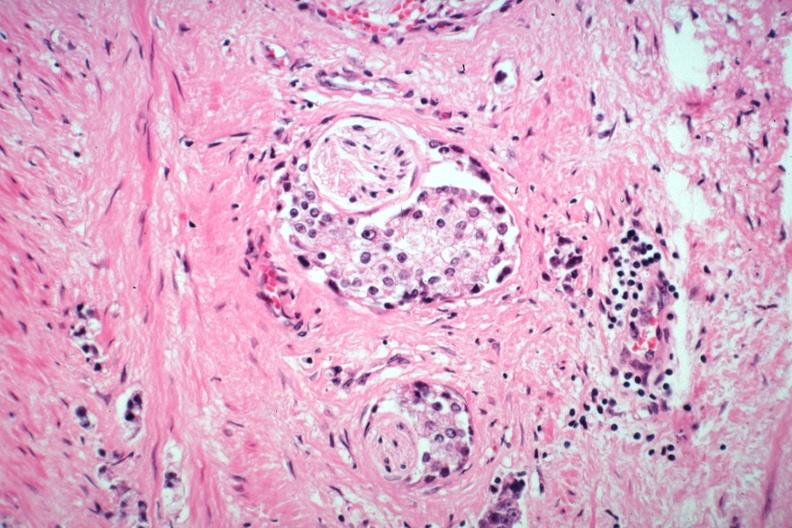s adenocarcinoma present?
Answer the question using a single word or phrase. Yes 